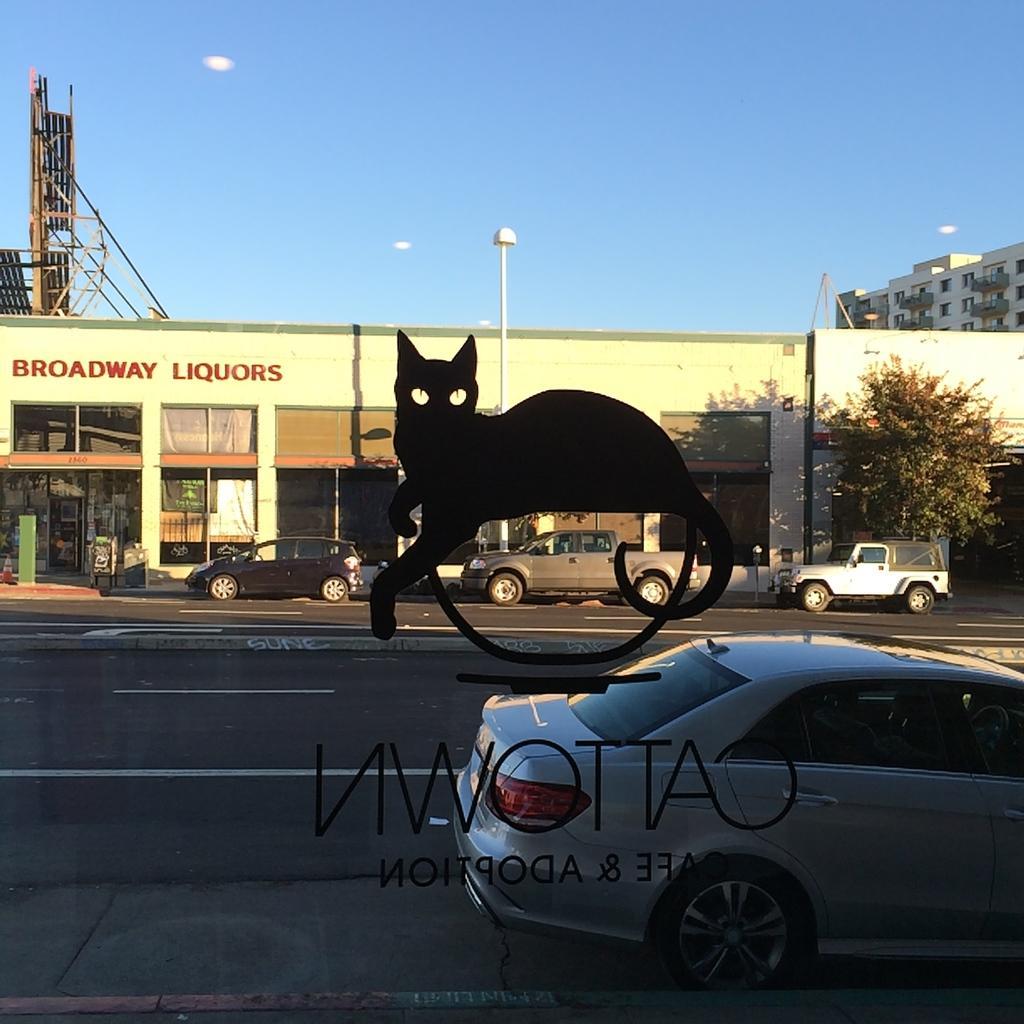Please provide a concise description of this image. In the foreground of the picture there is a glass, on the glass there is a sticker. Outside the class there are cars parked on the road. In the center of the picture there are buildings and tree. It is sunny. 